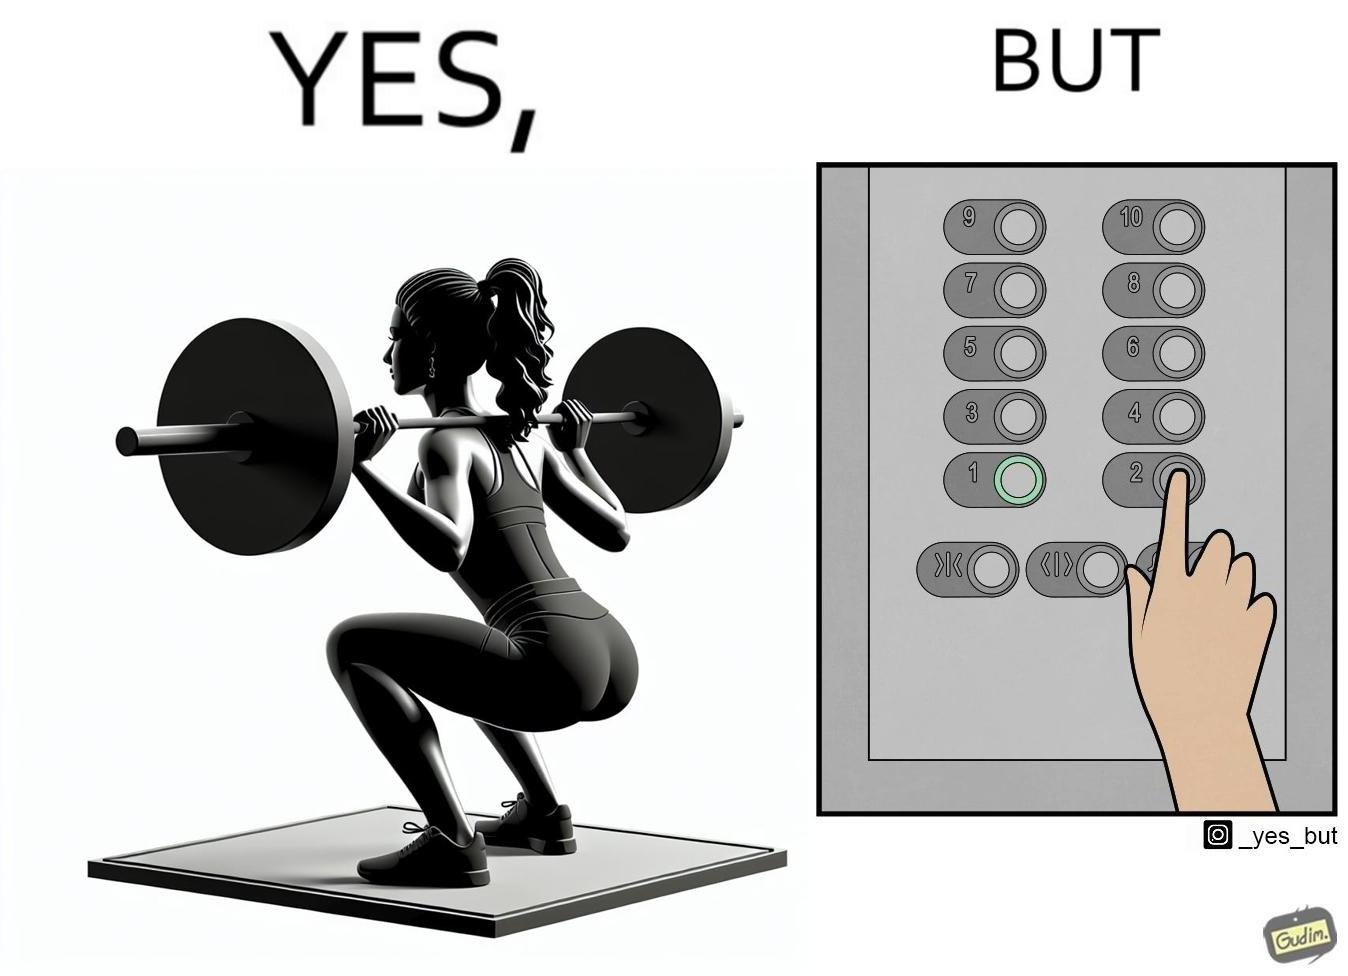Would you classify this image as satirical? Yes, this image is satirical. 